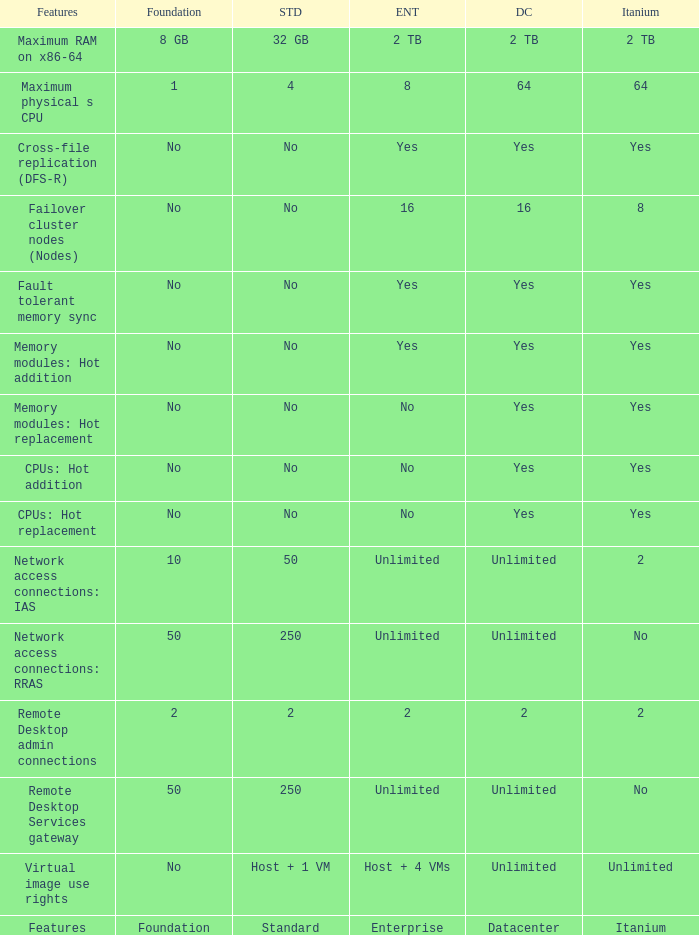What is the Enterprise for teh memory modules: hot replacement Feature that has a Datacenter of Yes? No. 